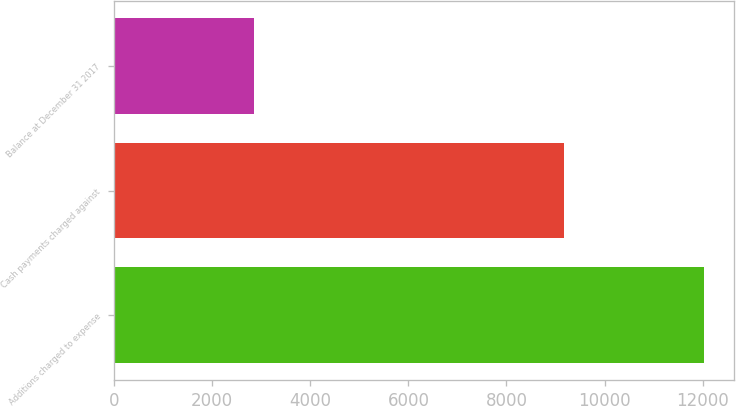<chart> <loc_0><loc_0><loc_500><loc_500><bar_chart><fcel>Additions charged to expense<fcel>Cash payments charged against<fcel>Balance at December 31 2017<nl><fcel>12029<fcel>9181<fcel>2848<nl></chart> 